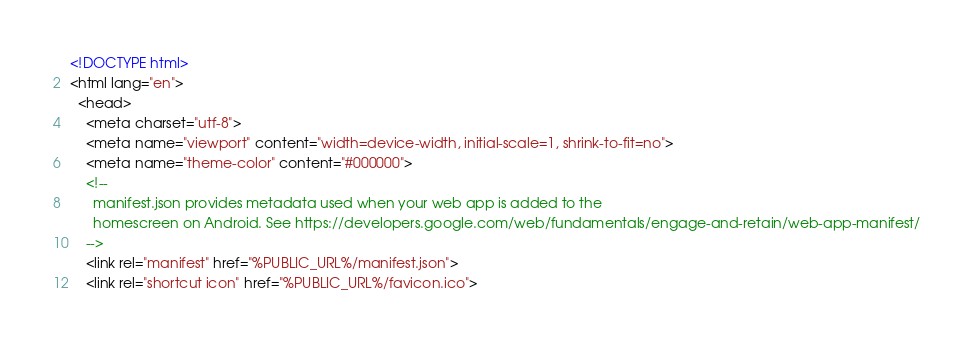<code> <loc_0><loc_0><loc_500><loc_500><_HTML_><!DOCTYPE html>
<html lang="en">
  <head>
    <meta charset="utf-8">
    <meta name="viewport" content="width=device-width, initial-scale=1, shrink-to-fit=no">
    <meta name="theme-color" content="#000000">
    <!--
      manifest.json provides metadata used when your web app is added to the
      homescreen on Android. See https://developers.google.com/web/fundamentals/engage-and-retain/web-app-manifest/
    -->
    <link rel="manifest" href="%PUBLIC_URL%/manifest.json">
    <link rel="shortcut icon" href="%PUBLIC_URL%/favicon.ico"></code> 